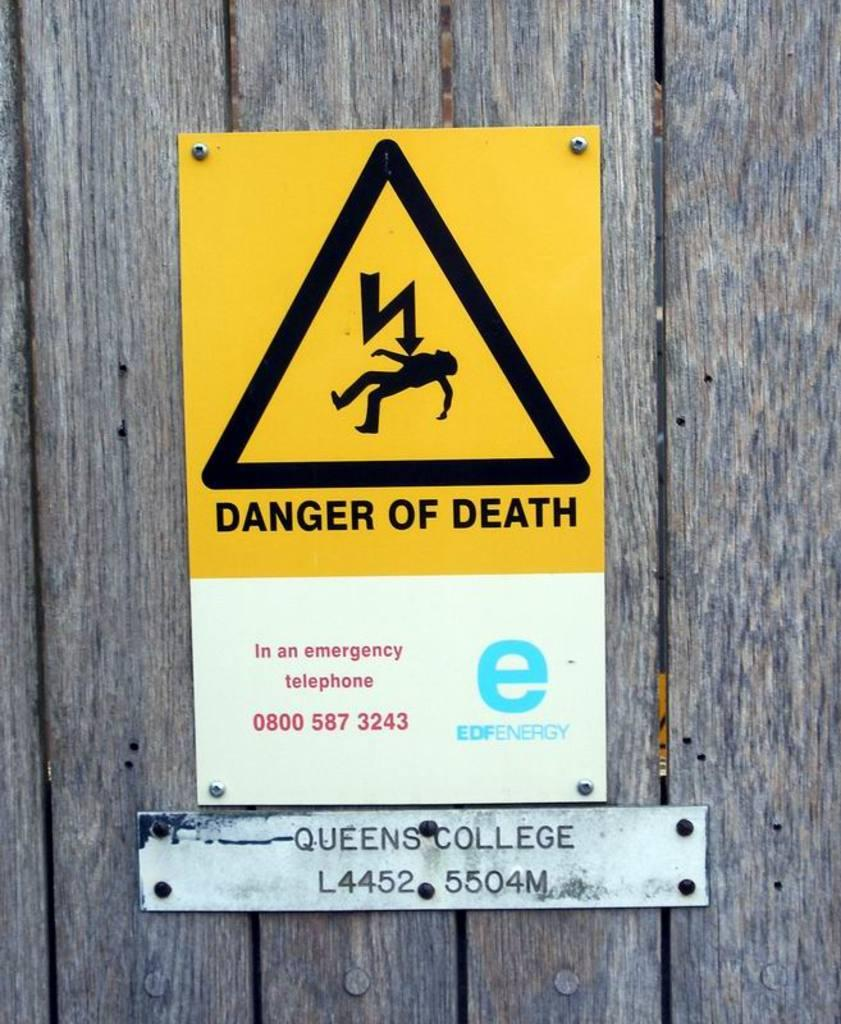Provide a one-sentence caption for the provided image. Danger of death sign on a wooden fence. 